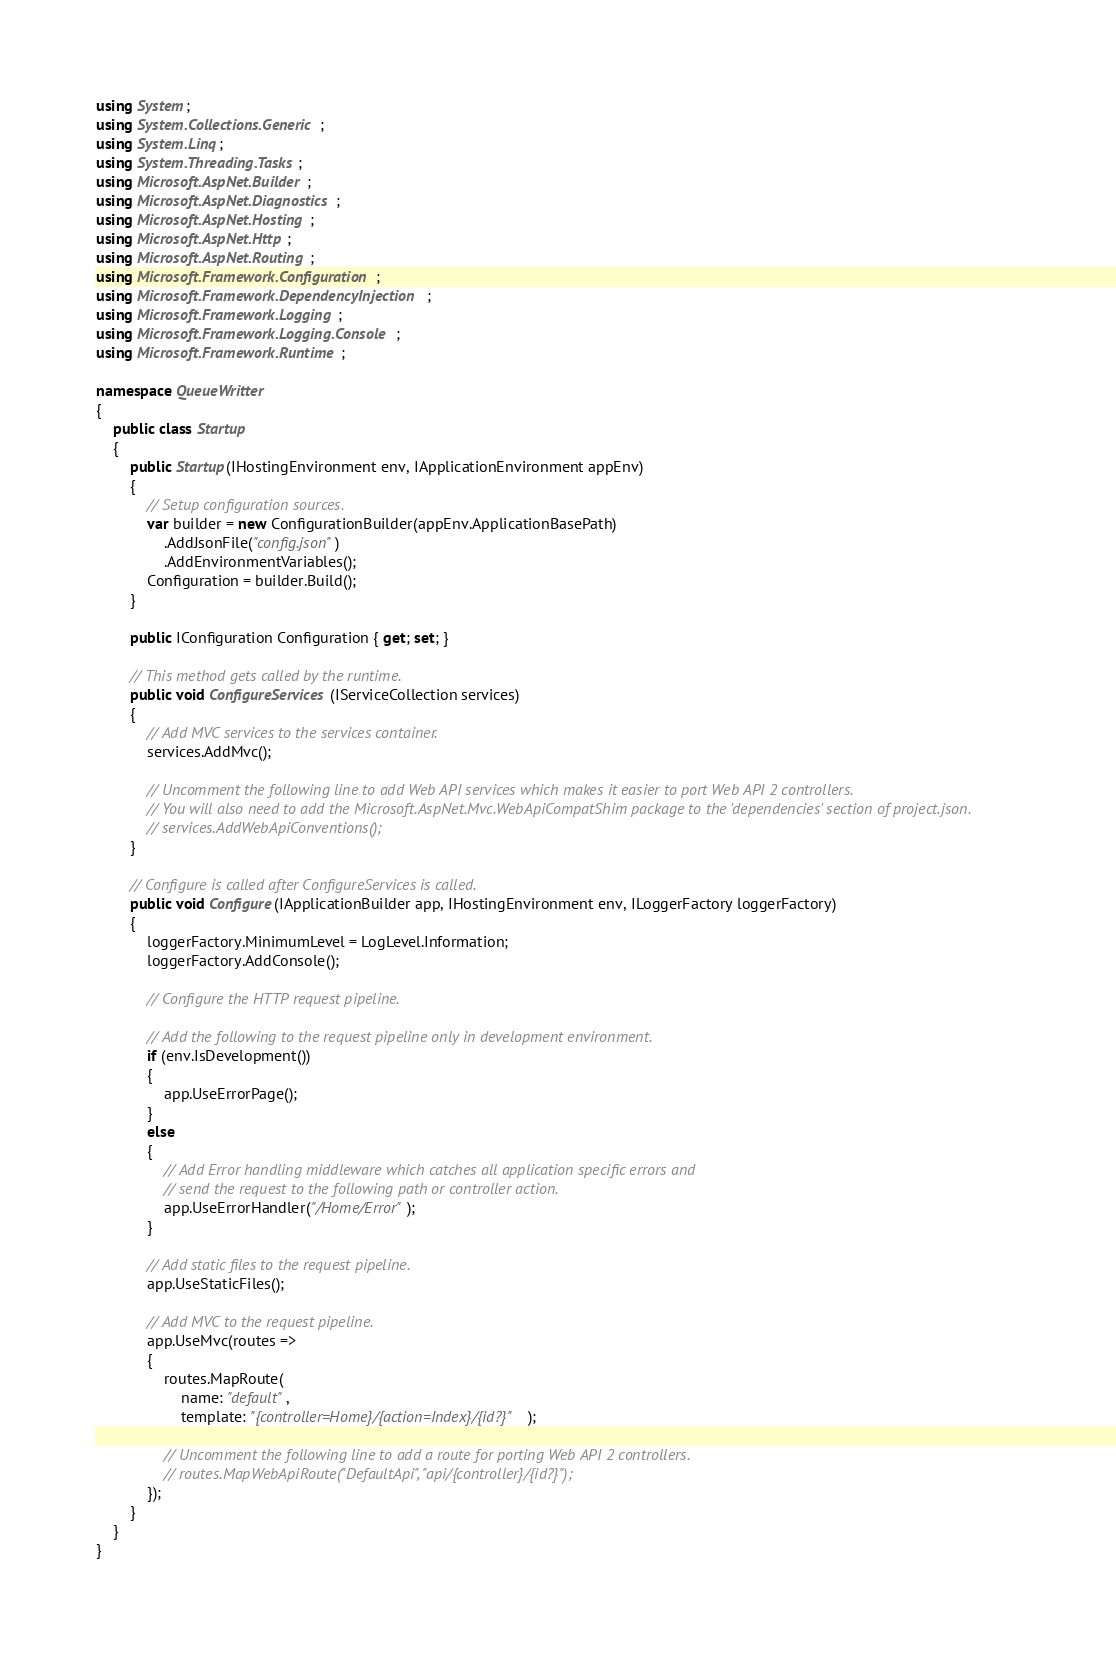<code> <loc_0><loc_0><loc_500><loc_500><_C#_>using System;
using System.Collections.Generic;
using System.Linq;
using System.Threading.Tasks;
using Microsoft.AspNet.Builder;
using Microsoft.AspNet.Diagnostics;
using Microsoft.AspNet.Hosting;
using Microsoft.AspNet.Http;
using Microsoft.AspNet.Routing;
using Microsoft.Framework.Configuration;
using Microsoft.Framework.DependencyInjection;
using Microsoft.Framework.Logging;
using Microsoft.Framework.Logging.Console;
using Microsoft.Framework.Runtime;

namespace QueueWritter
{
    public class Startup
    {
        public Startup(IHostingEnvironment env, IApplicationEnvironment appEnv)
        {
            // Setup configuration sources.
            var builder = new ConfigurationBuilder(appEnv.ApplicationBasePath)
                .AddJsonFile("config.json")
                .AddEnvironmentVariables();
            Configuration = builder.Build();
        }

        public IConfiguration Configuration { get; set; }

        // This method gets called by the runtime.
        public void ConfigureServices(IServiceCollection services)
        {
            // Add MVC services to the services container.
            services.AddMvc();

            // Uncomment the following line to add Web API services which makes it easier to port Web API 2 controllers.
            // You will also need to add the Microsoft.AspNet.Mvc.WebApiCompatShim package to the 'dependencies' section of project.json.
            // services.AddWebApiConventions();
        }

        // Configure is called after ConfigureServices is called.
        public void Configure(IApplicationBuilder app, IHostingEnvironment env, ILoggerFactory loggerFactory)
        {
            loggerFactory.MinimumLevel = LogLevel.Information;
            loggerFactory.AddConsole();

            // Configure the HTTP request pipeline.

            // Add the following to the request pipeline only in development environment.
            if (env.IsDevelopment())
            {
                app.UseErrorPage();
            }
            else
            {
                // Add Error handling middleware which catches all application specific errors and
                // send the request to the following path or controller action.
                app.UseErrorHandler("/Home/Error");
            }

            // Add static files to the request pipeline.
            app.UseStaticFiles();

            // Add MVC to the request pipeline.
            app.UseMvc(routes =>
            {
                routes.MapRoute(
                    name: "default",
                    template: "{controller=Home}/{action=Index}/{id?}");

                // Uncomment the following line to add a route for porting Web API 2 controllers.
                // routes.MapWebApiRoute("DefaultApi", "api/{controller}/{id?}");
            });
        }
    }
}
</code> 